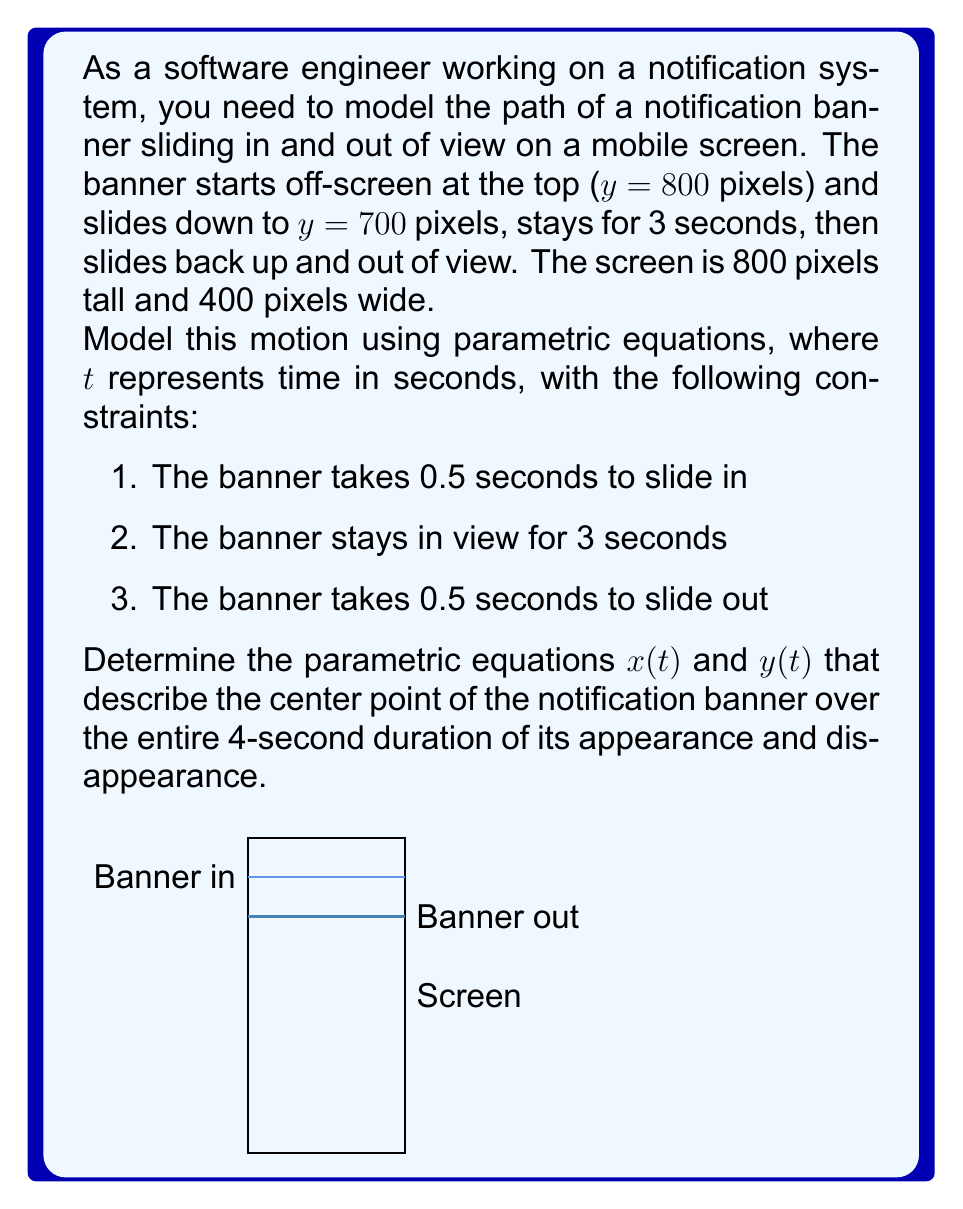What is the answer to this math problem? Let's break this problem down into steps:

1) First, we need to define our coordinate system. Let's set the origin (0,0) at the top-left corner of the screen, with x increasing to the right and y increasing downward.

2) The x-coordinate of the center of the banner doesn't change, so $x(t) = 200$ for all t.

3) For y(t), we need to define it piecewise over three intervals:
   - 0 ≤ t < 0.5: Sliding in
   - 0.5 ≤ t < 3.5: Stationary
   - 3.5 ≤ t ≤ 4: Sliding out

4) For the sliding in part (0 ≤ t < 0.5):
   - Start: y = 0 at t = 0
   - End: y = 700 at t = 0.5
   - This is linear motion, so we can use the equation:
     $y = mt + b$, where m = (700 - 0) / (0.5 - 0) = 1400
     $y(t) = 1400t$ for 0 ≤ t < 0.5

5) For the stationary part (0.5 ≤ t < 3.5):
   $y(t) = 700$

6) For the sliding out part (3.5 ≤ t ≤ 4):
   - Start: y = 700 at t = 3.5
   - End: y = 0 at t = 4
   - Again, linear motion:
     m = (0 - 700) / (4 - 3.5) = -1400
     $y(t) = -1400(t - 3.5) + 700$ for 3.5 ≤ t ≤ 4

7) Combining these, we get our piecewise function for y(t):

   $$y(t) = \begin{cases} 
   1400t & \text{if } 0 \leq t < 0.5 \\
   700 & \text{if } 0.5 \leq t < 3.5 \\
   -1400(t - 3.5) + 700 & \text{if } 3.5 \leq t \leq 4
   \end{cases}$$

Therefore, our parametric equations are:
$x(t) = 200$
$y(t)$ as defined in the piecewise function above.
Answer: $x(t) = 200$, $y(t) = \begin{cases} 1400t & \text{if } 0 \leq t < 0.5 \\ 700 & \text{if } 0.5 \leq t < 3.5 \\ -1400(t - 3.5) + 700 & \text{if } 3.5 \leq t \leq 4 \end{cases}$ 